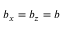<formula> <loc_0><loc_0><loc_500><loc_500>b _ { x } = b _ { z } = b</formula> 